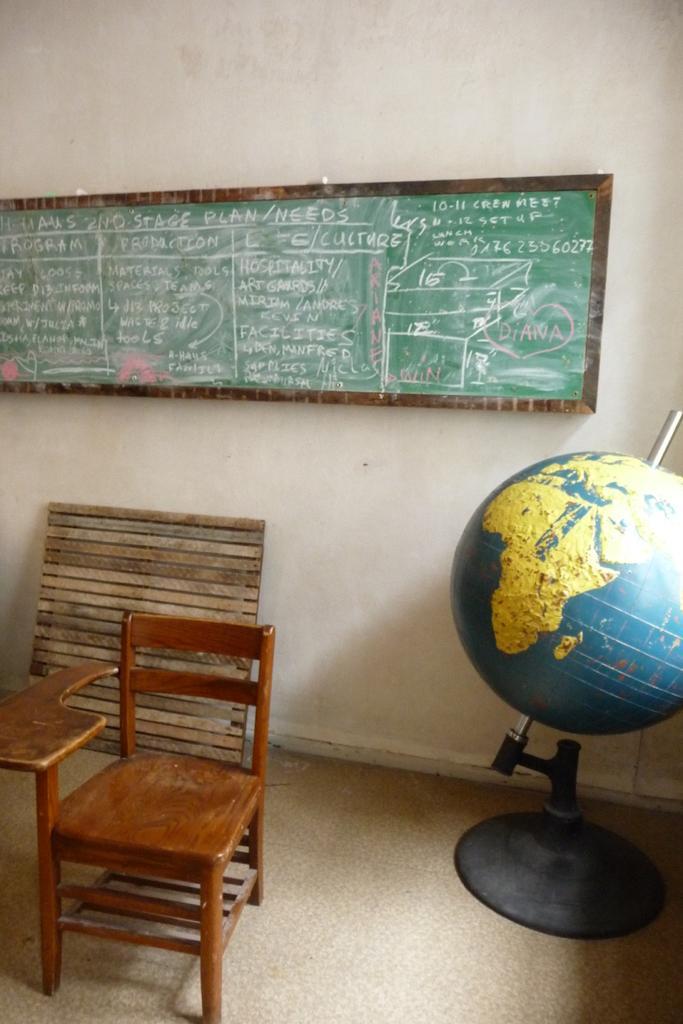Describe this image in one or two sentences. In the center of the image there is a board to the wall. On the left side of the image we can see table and chair. 